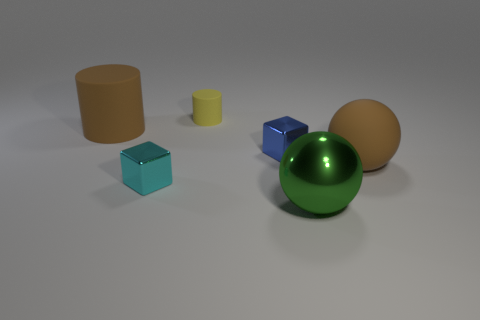There is a rubber object that is the same color as the large cylinder; what is its size?
Provide a succinct answer. Large. Are there any yellow blocks made of the same material as the green ball?
Provide a succinct answer. No. Are the tiny yellow thing that is to the left of the large brown sphere and the brown cylinder left of the big metallic thing made of the same material?
Your answer should be compact. Yes. What number of large brown rubber objects are there?
Give a very brief answer. 2. What shape is the small metal thing that is left of the tiny yellow matte cylinder?
Provide a short and direct response. Cube. How many other things are the same size as the blue block?
Make the answer very short. 2. Do the big rubber object that is to the left of the tiny yellow cylinder and the big matte thing right of the cyan metal object have the same shape?
Offer a very short reply. No. How many small yellow rubber cylinders are behind the small yellow thing?
Provide a short and direct response. 0. There is a cube that is to the right of the cyan metal thing; what is its color?
Give a very brief answer. Blue. What is the color of the other object that is the same shape as the large green thing?
Your response must be concise. Brown. 